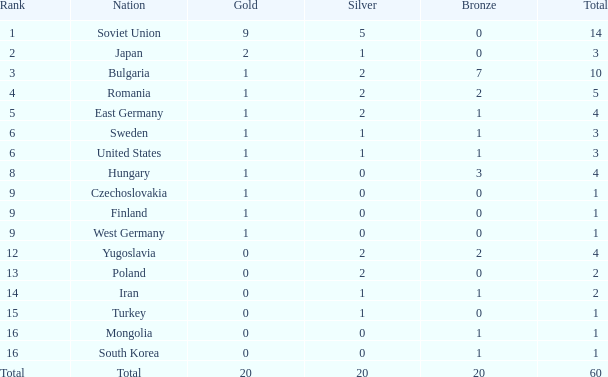What is the sum of totals featuring silvers under 2, bronzes over 0, and golds beyond 1? 0.0. 